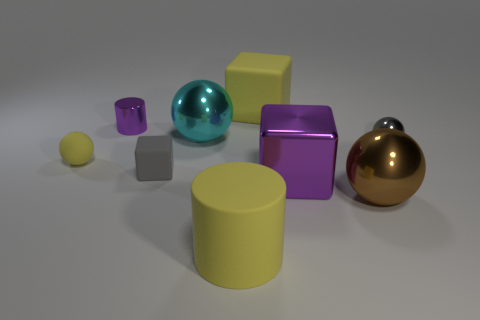Add 1 purple matte cylinders. How many objects exist? 10 Subtract all cubes. How many objects are left? 6 Subtract all brown spheres. How many spheres are left? 3 Subtract all matte blocks. How many blocks are left? 1 Subtract 1 cubes. How many cubes are left? 2 Subtract all blue blocks. Subtract all blue balls. How many blocks are left? 3 Subtract all yellow cylinders. How many green blocks are left? 0 Subtract all tiny rubber balls. Subtract all yellow matte balls. How many objects are left? 7 Add 5 large brown things. How many large brown things are left? 6 Add 6 tiny purple things. How many tiny purple things exist? 7 